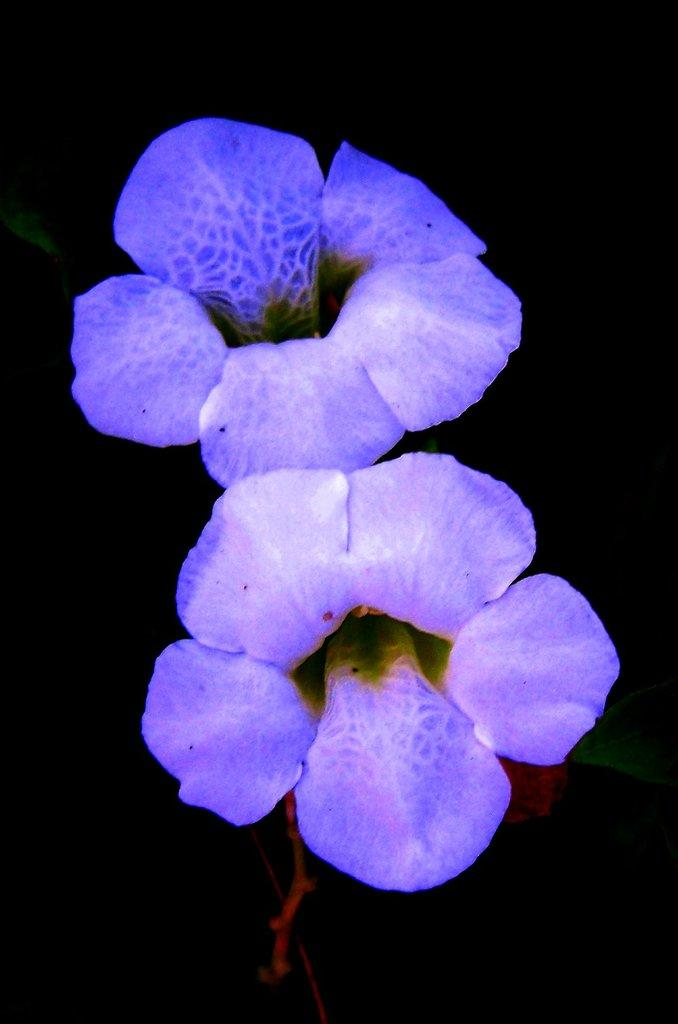What is the main subject of the image? The main subject of the image is flowers. Where are the flowers located in the image? The flowers are in the center of the image. What color is the background of the image? The background of the image is black in color. What type of yarn is being used to create the flowers in the image? There is no yarn present in the image; the flowers are real flowers. Can you tell me who the flowers are crushing in the image? There is no indication of any crushing or interaction with other objects in the image; the flowers are simply in the center of the image. 